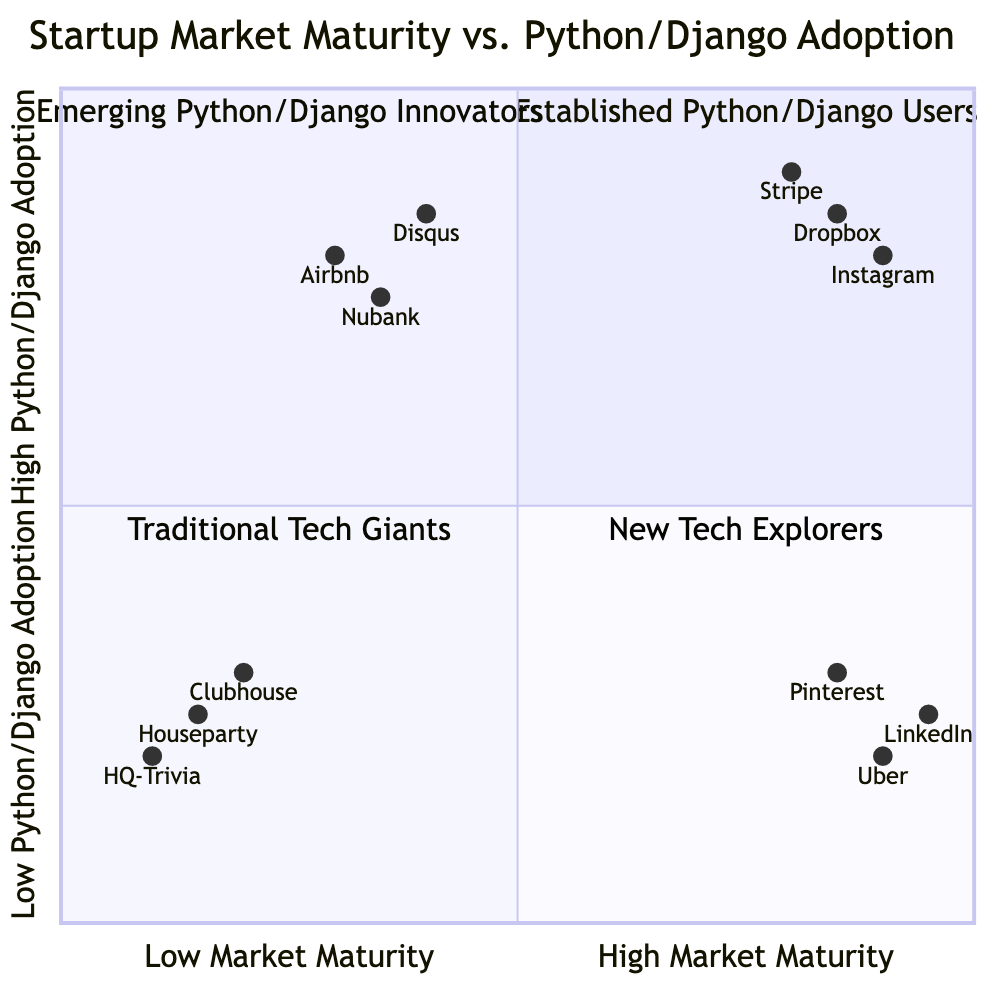What companies are in the "High Market Maturity, High Python/Django Adoption" quadrant? The "High Market Maturity, High Python/Django Adoption" quadrant consists of established startups that significantly utilize Python/Django technologies. Based on the provided data, the examples given in this quadrant are Stripe, Dropbox, and Instagram.
Answer: Stripe, Dropbox, Instagram Which company represents "Low Market Maturity, High Python/Django Adoption"? The "Low Market Maturity, High Python/Django Adoption" quadrant includes emerging startups adopting Python/Django for their core products. Given the examples, Airbnb (in its early stage) is one of the companies representative of this quadrant.
Answer: Airbnb How many companies are in the "Low Market Maturity, Low Python/Django Adoption" quadrant? The "Low Market Maturity, Low Python/Django Adoption" quadrant features startups that are newer or operating in niche markets. From the provided examples, there are three companies listed: Clubhouse, Houseparty, and HQ Trivia, making a total of three companies.
Answer: 3 What is the relationship between "Uber" and "Python/Django Adoption" in the diagram? Uber is positioned in the "High Market Maturity, Low Python/Django Adoption" quadrant, which indicates that while it is an established startup with significant market presence, it does not prefer to adopt Python/Django technologies.
Answer: Low Python/Django Adoption What quadrant contains "Pinterest"? Pinterest is located in the "High Market Maturity, Low Python/Django Adoption" quadrant. This indicates that, similar to Uber, Pinterest has a strong market presence but opts for technologies other than Python/Django.
Answer: High Market Maturity, Low Python/Django Adoption Which quadrant showcases companies in their initial phase of market development? The quadrant that illustrates companies in their initial phase of market development is called "Low Market Maturity, High Python/Django Adoption." This reflects companies that are emerging and using Python/Django technologies for their product development.
Answer: Low Market Maturity, High Python/Django Adoption Name a company from the "High Market Maturity, Low Python/Django Adoption" quadrant. A notable example from the "High Market Maturity, Low Python/Django Adoption" quadrant is LinkedIn, which, despite its strong market presence, does not utilize Python/Django significantly as part of its technology stack.
Answer: LinkedIn What defines the "New Tech Explorers" quadrant? The "New Tech Explorers" quadrant, identified as "Low Market Maturity, Low Python/Django Adoption," is characterized by newer startups or those functioning within niche markets that have limited adoption of Python/Django technologies.
Answer: New Tech Explorers 